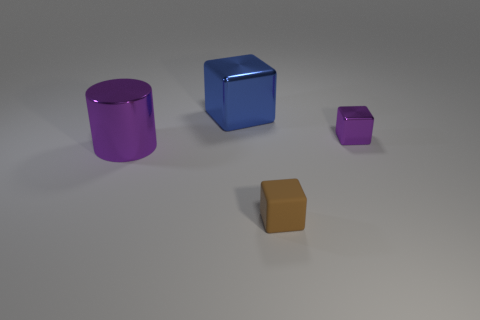Add 1 large gray metallic blocks. How many objects exist? 5 Subtract all cylinders. How many objects are left? 3 Add 3 small brown matte blocks. How many small brown matte blocks are left? 4 Add 3 brown objects. How many brown objects exist? 4 Subtract 0 yellow cylinders. How many objects are left? 4 Subtract all gray cubes. Subtract all tiny brown cubes. How many objects are left? 3 